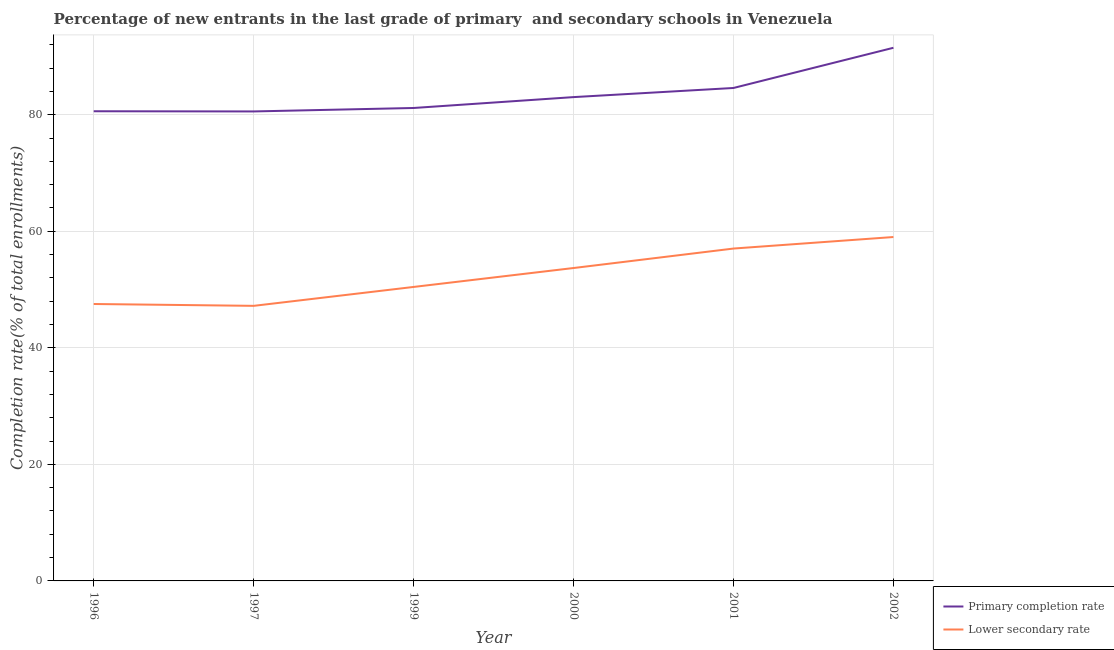What is the completion rate in primary schools in 1996?
Make the answer very short. 80.59. Across all years, what is the maximum completion rate in secondary schools?
Offer a very short reply. 59.01. Across all years, what is the minimum completion rate in secondary schools?
Your response must be concise. 47.2. In which year was the completion rate in secondary schools maximum?
Provide a short and direct response. 2002. What is the total completion rate in primary schools in the graph?
Your response must be concise. 501.4. What is the difference between the completion rate in primary schools in 1999 and that in 2000?
Offer a very short reply. -1.87. What is the difference between the completion rate in primary schools in 1996 and the completion rate in secondary schools in 2002?
Give a very brief answer. 21.58. What is the average completion rate in primary schools per year?
Your response must be concise. 83.57. In the year 1999, what is the difference between the completion rate in secondary schools and completion rate in primary schools?
Make the answer very short. -30.71. In how many years, is the completion rate in primary schools greater than 32 %?
Keep it short and to the point. 6. What is the ratio of the completion rate in secondary schools in 2001 to that in 2002?
Keep it short and to the point. 0.97. Is the completion rate in primary schools in 2000 less than that in 2001?
Ensure brevity in your answer.  Yes. Is the difference between the completion rate in secondary schools in 1999 and 2001 greater than the difference between the completion rate in primary schools in 1999 and 2001?
Provide a short and direct response. No. What is the difference between the highest and the second highest completion rate in primary schools?
Make the answer very short. 6.9. What is the difference between the highest and the lowest completion rate in secondary schools?
Provide a short and direct response. 11.81. Is the sum of the completion rate in primary schools in 1999 and 2001 greater than the maximum completion rate in secondary schools across all years?
Keep it short and to the point. Yes. Does the completion rate in secondary schools monotonically increase over the years?
Keep it short and to the point. No. Is the completion rate in secondary schools strictly greater than the completion rate in primary schools over the years?
Your answer should be compact. No. How many lines are there?
Provide a succinct answer. 2. Are the values on the major ticks of Y-axis written in scientific E-notation?
Your response must be concise. No. Does the graph contain any zero values?
Make the answer very short. No. Does the graph contain grids?
Your answer should be very brief. Yes. Where does the legend appear in the graph?
Give a very brief answer. Bottom right. How many legend labels are there?
Make the answer very short. 2. How are the legend labels stacked?
Offer a very short reply. Vertical. What is the title of the graph?
Offer a terse response. Percentage of new entrants in the last grade of primary  and secondary schools in Venezuela. Does "Current US$" appear as one of the legend labels in the graph?
Your response must be concise. No. What is the label or title of the X-axis?
Your response must be concise. Year. What is the label or title of the Y-axis?
Offer a terse response. Completion rate(% of total enrollments). What is the Completion rate(% of total enrollments) in Primary completion rate in 1996?
Keep it short and to the point. 80.59. What is the Completion rate(% of total enrollments) in Lower secondary rate in 1996?
Your answer should be compact. 47.52. What is the Completion rate(% of total enrollments) in Primary completion rate in 1997?
Make the answer very short. 80.56. What is the Completion rate(% of total enrollments) of Lower secondary rate in 1997?
Your response must be concise. 47.2. What is the Completion rate(% of total enrollments) of Primary completion rate in 1999?
Your answer should be very brief. 81.15. What is the Completion rate(% of total enrollments) of Lower secondary rate in 1999?
Your response must be concise. 50.44. What is the Completion rate(% of total enrollments) in Primary completion rate in 2000?
Offer a very short reply. 83.02. What is the Completion rate(% of total enrollments) in Lower secondary rate in 2000?
Offer a terse response. 53.69. What is the Completion rate(% of total enrollments) in Primary completion rate in 2001?
Keep it short and to the point. 84.59. What is the Completion rate(% of total enrollments) in Lower secondary rate in 2001?
Ensure brevity in your answer.  57.03. What is the Completion rate(% of total enrollments) of Primary completion rate in 2002?
Your answer should be very brief. 91.48. What is the Completion rate(% of total enrollments) in Lower secondary rate in 2002?
Give a very brief answer. 59.01. Across all years, what is the maximum Completion rate(% of total enrollments) of Primary completion rate?
Provide a short and direct response. 91.48. Across all years, what is the maximum Completion rate(% of total enrollments) in Lower secondary rate?
Keep it short and to the point. 59.01. Across all years, what is the minimum Completion rate(% of total enrollments) of Primary completion rate?
Provide a succinct answer. 80.56. Across all years, what is the minimum Completion rate(% of total enrollments) in Lower secondary rate?
Provide a short and direct response. 47.2. What is the total Completion rate(% of total enrollments) in Primary completion rate in the graph?
Offer a terse response. 501.4. What is the total Completion rate(% of total enrollments) of Lower secondary rate in the graph?
Offer a terse response. 314.9. What is the difference between the Completion rate(% of total enrollments) of Primary completion rate in 1996 and that in 1997?
Make the answer very short. 0.03. What is the difference between the Completion rate(% of total enrollments) in Lower secondary rate in 1996 and that in 1997?
Ensure brevity in your answer.  0.32. What is the difference between the Completion rate(% of total enrollments) in Primary completion rate in 1996 and that in 1999?
Give a very brief answer. -0.56. What is the difference between the Completion rate(% of total enrollments) in Lower secondary rate in 1996 and that in 1999?
Offer a very short reply. -2.93. What is the difference between the Completion rate(% of total enrollments) in Primary completion rate in 1996 and that in 2000?
Your answer should be very brief. -2.42. What is the difference between the Completion rate(% of total enrollments) of Lower secondary rate in 1996 and that in 2000?
Offer a very short reply. -6.18. What is the difference between the Completion rate(% of total enrollments) in Primary completion rate in 1996 and that in 2001?
Make the answer very short. -3.99. What is the difference between the Completion rate(% of total enrollments) in Lower secondary rate in 1996 and that in 2001?
Offer a very short reply. -9.52. What is the difference between the Completion rate(% of total enrollments) in Primary completion rate in 1996 and that in 2002?
Your answer should be compact. -10.89. What is the difference between the Completion rate(% of total enrollments) of Lower secondary rate in 1996 and that in 2002?
Your answer should be very brief. -11.49. What is the difference between the Completion rate(% of total enrollments) in Primary completion rate in 1997 and that in 1999?
Ensure brevity in your answer.  -0.59. What is the difference between the Completion rate(% of total enrollments) of Lower secondary rate in 1997 and that in 1999?
Make the answer very short. -3.24. What is the difference between the Completion rate(% of total enrollments) of Primary completion rate in 1997 and that in 2000?
Offer a very short reply. -2.46. What is the difference between the Completion rate(% of total enrollments) of Lower secondary rate in 1997 and that in 2000?
Your answer should be compact. -6.49. What is the difference between the Completion rate(% of total enrollments) in Primary completion rate in 1997 and that in 2001?
Provide a short and direct response. -4.03. What is the difference between the Completion rate(% of total enrollments) of Lower secondary rate in 1997 and that in 2001?
Your answer should be very brief. -9.83. What is the difference between the Completion rate(% of total enrollments) in Primary completion rate in 1997 and that in 2002?
Your answer should be compact. -10.92. What is the difference between the Completion rate(% of total enrollments) in Lower secondary rate in 1997 and that in 2002?
Your answer should be compact. -11.81. What is the difference between the Completion rate(% of total enrollments) of Primary completion rate in 1999 and that in 2000?
Provide a succinct answer. -1.87. What is the difference between the Completion rate(% of total enrollments) of Lower secondary rate in 1999 and that in 2000?
Offer a terse response. -3.25. What is the difference between the Completion rate(% of total enrollments) of Primary completion rate in 1999 and that in 2001?
Give a very brief answer. -3.43. What is the difference between the Completion rate(% of total enrollments) in Lower secondary rate in 1999 and that in 2001?
Make the answer very short. -6.59. What is the difference between the Completion rate(% of total enrollments) in Primary completion rate in 1999 and that in 2002?
Your answer should be compact. -10.33. What is the difference between the Completion rate(% of total enrollments) in Lower secondary rate in 1999 and that in 2002?
Your answer should be very brief. -8.57. What is the difference between the Completion rate(% of total enrollments) in Primary completion rate in 2000 and that in 2001?
Offer a very short reply. -1.57. What is the difference between the Completion rate(% of total enrollments) in Lower secondary rate in 2000 and that in 2001?
Give a very brief answer. -3.34. What is the difference between the Completion rate(% of total enrollments) of Primary completion rate in 2000 and that in 2002?
Make the answer very short. -8.47. What is the difference between the Completion rate(% of total enrollments) of Lower secondary rate in 2000 and that in 2002?
Give a very brief answer. -5.32. What is the difference between the Completion rate(% of total enrollments) of Primary completion rate in 2001 and that in 2002?
Your answer should be very brief. -6.9. What is the difference between the Completion rate(% of total enrollments) in Lower secondary rate in 2001 and that in 2002?
Your answer should be very brief. -1.98. What is the difference between the Completion rate(% of total enrollments) in Primary completion rate in 1996 and the Completion rate(% of total enrollments) in Lower secondary rate in 1997?
Offer a terse response. 33.39. What is the difference between the Completion rate(% of total enrollments) of Primary completion rate in 1996 and the Completion rate(% of total enrollments) of Lower secondary rate in 1999?
Your answer should be very brief. 30.15. What is the difference between the Completion rate(% of total enrollments) in Primary completion rate in 1996 and the Completion rate(% of total enrollments) in Lower secondary rate in 2000?
Offer a very short reply. 26.9. What is the difference between the Completion rate(% of total enrollments) in Primary completion rate in 1996 and the Completion rate(% of total enrollments) in Lower secondary rate in 2001?
Your answer should be very brief. 23.56. What is the difference between the Completion rate(% of total enrollments) of Primary completion rate in 1996 and the Completion rate(% of total enrollments) of Lower secondary rate in 2002?
Your answer should be compact. 21.58. What is the difference between the Completion rate(% of total enrollments) of Primary completion rate in 1997 and the Completion rate(% of total enrollments) of Lower secondary rate in 1999?
Give a very brief answer. 30.12. What is the difference between the Completion rate(% of total enrollments) of Primary completion rate in 1997 and the Completion rate(% of total enrollments) of Lower secondary rate in 2000?
Give a very brief answer. 26.87. What is the difference between the Completion rate(% of total enrollments) in Primary completion rate in 1997 and the Completion rate(% of total enrollments) in Lower secondary rate in 2001?
Give a very brief answer. 23.53. What is the difference between the Completion rate(% of total enrollments) in Primary completion rate in 1997 and the Completion rate(% of total enrollments) in Lower secondary rate in 2002?
Keep it short and to the point. 21.55. What is the difference between the Completion rate(% of total enrollments) in Primary completion rate in 1999 and the Completion rate(% of total enrollments) in Lower secondary rate in 2000?
Give a very brief answer. 27.46. What is the difference between the Completion rate(% of total enrollments) in Primary completion rate in 1999 and the Completion rate(% of total enrollments) in Lower secondary rate in 2001?
Your response must be concise. 24.12. What is the difference between the Completion rate(% of total enrollments) in Primary completion rate in 1999 and the Completion rate(% of total enrollments) in Lower secondary rate in 2002?
Make the answer very short. 22.14. What is the difference between the Completion rate(% of total enrollments) of Primary completion rate in 2000 and the Completion rate(% of total enrollments) of Lower secondary rate in 2001?
Ensure brevity in your answer.  25.99. What is the difference between the Completion rate(% of total enrollments) in Primary completion rate in 2000 and the Completion rate(% of total enrollments) in Lower secondary rate in 2002?
Your response must be concise. 24.01. What is the difference between the Completion rate(% of total enrollments) of Primary completion rate in 2001 and the Completion rate(% of total enrollments) of Lower secondary rate in 2002?
Offer a terse response. 25.58. What is the average Completion rate(% of total enrollments) of Primary completion rate per year?
Offer a terse response. 83.57. What is the average Completion rate(% of total enrollments) in Lower secondary rate per year?
Your response must be concise. 52.48. In the year 1996, what is the difference between the Completion rate(% of total enrollments) in Primary completion rate and Completion rate(% of total enrollments) in Lower secondary rate?
Offer a terse response. 33.08. In the year 1997, what is the difference between the Completion rate(% of total enrollments) of Primary completion rate and Completion rate(% of total enrollments) of Lower secondary rate?
Offer a very short reply. 33.36. In the year 1999, what is the difference between the Completion rate(% of total enrollments) of Primary completion rate and Completion rate(% of total enrollments) of Lower secondary rate?
Give a very brief answer. 30.71. In the year 2000, what is the difference between the Completion rate(% of total enrollments) of Primary completion rate and Completion rate(% of total enrollments) of Lower secondary rate?
Make the answer very short. 29.33. In the year 2001, what is the difference between the Completion rate(% of total enrollments) in Primary completion rate and Completion rate(% of total enrollments) in Lower secondary rate?
Keep it short and to the point. 27.55. In the year 2002, what is the difference between the Completion rate(% of total enrollments) of Primary completion rate and Completion rate(% of total enrollments) of Lower secondary rate?
Your response must be concise. 32.47. What is the ratio of the Completion rate(% of total enrollments) in Lower secondary rate in 1996 to that in 1997?
Provide a short and direct response. 1.01. What is the ratio of the Completion rate(% of total enrollments) of Primary completion rate in 1996 to that in 1999?
Offer a very short reply. 0.99. What is the ratio of the Completion rate(% of total enrollments) of Lower secondary rate in 1996 to that in 1999?
Provide a short and direct response. 0.94. What is the ratio of the Completion rate(% of total enrollments) of Primary completion rate in 1996 to that in 2000?
Provide a short and direct response. 0.97. What is the ratio of the Completion rate(% of total enrollments) of Lower secondary rate in 1996 to that in 2000?
Your answer should be compact. 0.89. What is the ratio of the Completion rate(% of total enrollments) of Primary completion rate in 1996 to that in 2001?
Keep it short and to the point. 0.95. What is the ratio of the Completion rate(% of total enrollments) in Lower secondary rate in 1996 to that in 2001?
Ensure brevity in your answer.  0.83. What is the ratio of the Completion rate(% of total enrollments) of Primary completion rate in 1996 to that in 2002?
Provide a succinct answer. 0.88. What is the ratio of the Completion rate(% of total enrollments) in Lower secondary rate in 1996 to that in 2002?
Ensure brevity in your answer.  0.81. What is the ratio of the Completion rate(% of total enrollments) of Lower secondary rate in 1997 to that in 1999?
Provide a short and direct response. 0.94. What is the ratio of the Completion rate(% of total enrollments) in Primary completion rate in 1997 to that in 2000?
Your answer should be compact. 0.97. What is the ratio of the Completion rate(% of total enrollments) in Lower secondary rate in 1997 to that in 2000?
Your answer should be compact. 0.88. What is the ratio of the Completion rate(% of total enrollments) in Primary completion rate in 1997 to that in 2001?
Offer a terse response. 0.95. What is the ratio of the Completion rate(% of total enrollments) of Lower secondary rate in 1997 to that in 2001?
Provide a succinct answer. 0.83. What is the ratio of the Completion rate(% of total enrollments) of Primary completion rate in 1997 to that in 2002?
Give a very brief answer. 0.88. What is the ratio of the Completion rate(% of total enrollments) of Lower secondary rate in 1997 to that in 2002?
Keep it short and to the point. 0.8. What is the ratio of the Completion rate(% of total enrollments) in Primary completion rate in 1999 to that in 2000?
Give a very brief answer. 0.98. What is the ratio of the Completion rate(% of total enrollments) in Lower secondary rate in 1999 to that in 2000?
Provide a short and direct response. 0.94. What is the ratio of the Completion rate(% of total enrollments) in Primary completion rate in 1999 to that in 2001?
Offer a terse response. 0.96. What is the ratio of the Completion rate(% of total enrollments) in Lower secondary rate in 1999 to that in 2001?
Your response must be concise. 0.88. What is the ratio of the Completion rate(% of total enrollments) of Primary completion rate in 1999 to that in 2002?
Offer a terse response. 0.89. What is the ratio of the Completion rate(% of total enrollments) in Lower secondary rate in 1999 to that in 2002?
Ensure brevity in your answer.  0.85. What is the ratio of the Completion rate(% of total enrollments) of Primary completion rate in 2000 to that in 2001?
Give a very brief answer. 0.98. What is the ratio of the Completion rate(% of total enrollments) of Lower secondary rate in 2000 to that in 2001?
Offer a very short reply. 0.94. What is the ratio of the Completion rate(% of total enrollments) in Primary completion rate in 2000 to that in 2002?
Your answer should be compact. 0.91. What is the ratio of the Completion rate(% of total enrollments) of Lower secondary rate in 2000 to that in 2002?
Your response must be concise. 0.91. What is the ratio of the Completion rate(% of total enrollments) in Primary completion rate in 2001 to that in 2002?
Ensure brevity in your answer.  0.92. What is the ratio of the Completion rate(% of total enrollments) in Lower secondary rate in 2001 to that in 2002?
Ensure brevity in your answer.  0.97. What is the difference between the highest and the second highest Completion rate(% of total enrollments) of Primary completion rate?
Your answer should be compact. 6.9. What is the difference between the highest and the second highest Completion rate(% of total enrollments) in Lower secondary rate?
Provide a succinct answer. 1.98. What is the difference between the highest and the lowest Completion rate(% of total enrollments) of Primary completion rate?
Provide a succinct answer. 10.92. What is the difference between the highest and the lowest Completion rate(% of total enrollments) in Lower secondary rate?
Make the answer very short. 11.81. 